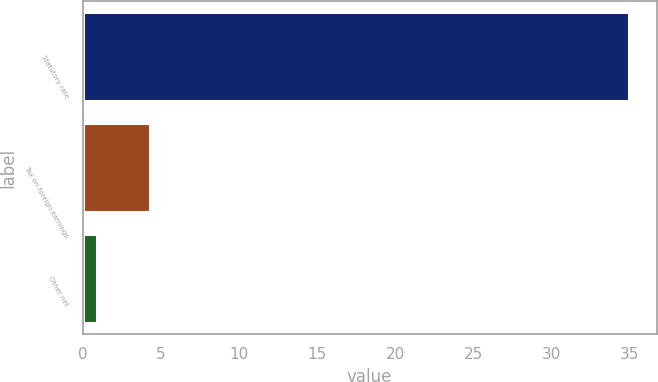Convert chart. <chart><loc_0><loc_0><loc_500><loc_500><bar_chart><fcel>Statutory rate<fcel>Tax on foreign earnings<fcel>Other net<nl><fcel>35<fcel>4.31<fcel>0.9<nl></chart> 